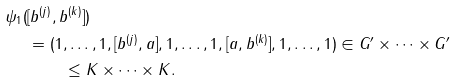<formula> <loc_0><loc_0><loc_500><loc_500>\psi _ { 1 } ( & [ b ^ { ( j ) } , b ^ { ( k ) } ] ) \\ & = ( 1 , \dots , 1 , [ b ^ { ( j ) } , a ] , 1 , \dots , 1 , [ a , b ^ { ( k ) } ] , 1 , \dots , 1 ) \in G ^ { \prime } \times \dots \times G ^ { \prime } \\ & \quad \, \quad \leq K \times \dots \times K .</formula> 